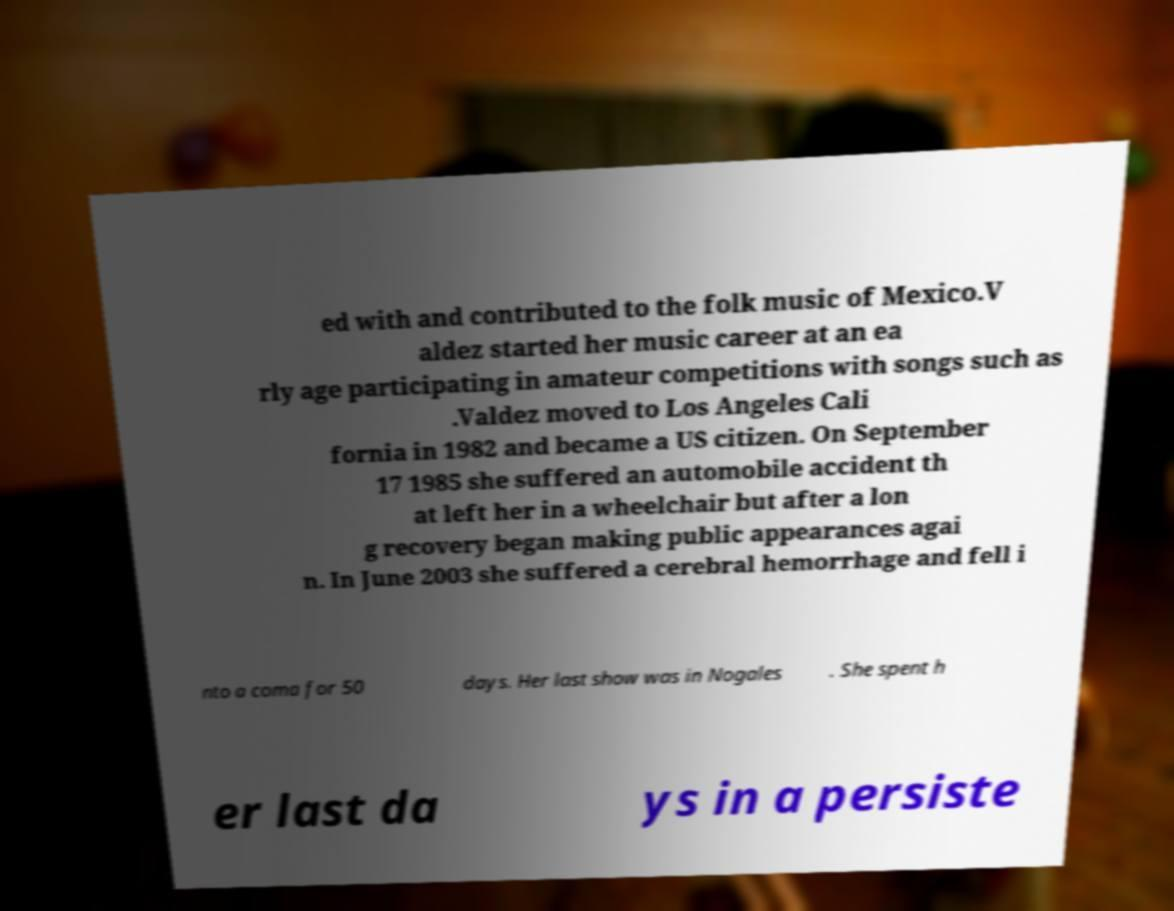I need the written content from this picture converted into text. Can you do that? ed with and contributed to the folk music of Mexico.V aldez started her music career at an ea rly age participating in amateur competitions with songs such as .Valdez moved to Los Angeles Cali fornia in 1982 and became a US citizen. On September 17 1985 she suffered an automobile accident th at left her in a wheelchair but after a lon g recovery began making public appearances agai n. In June 2003 she suffered a cerebral hemorrhage and fell i nto a coma for 50 days. Her last show was in Nogales . She spent h er last da ys in a persiste 